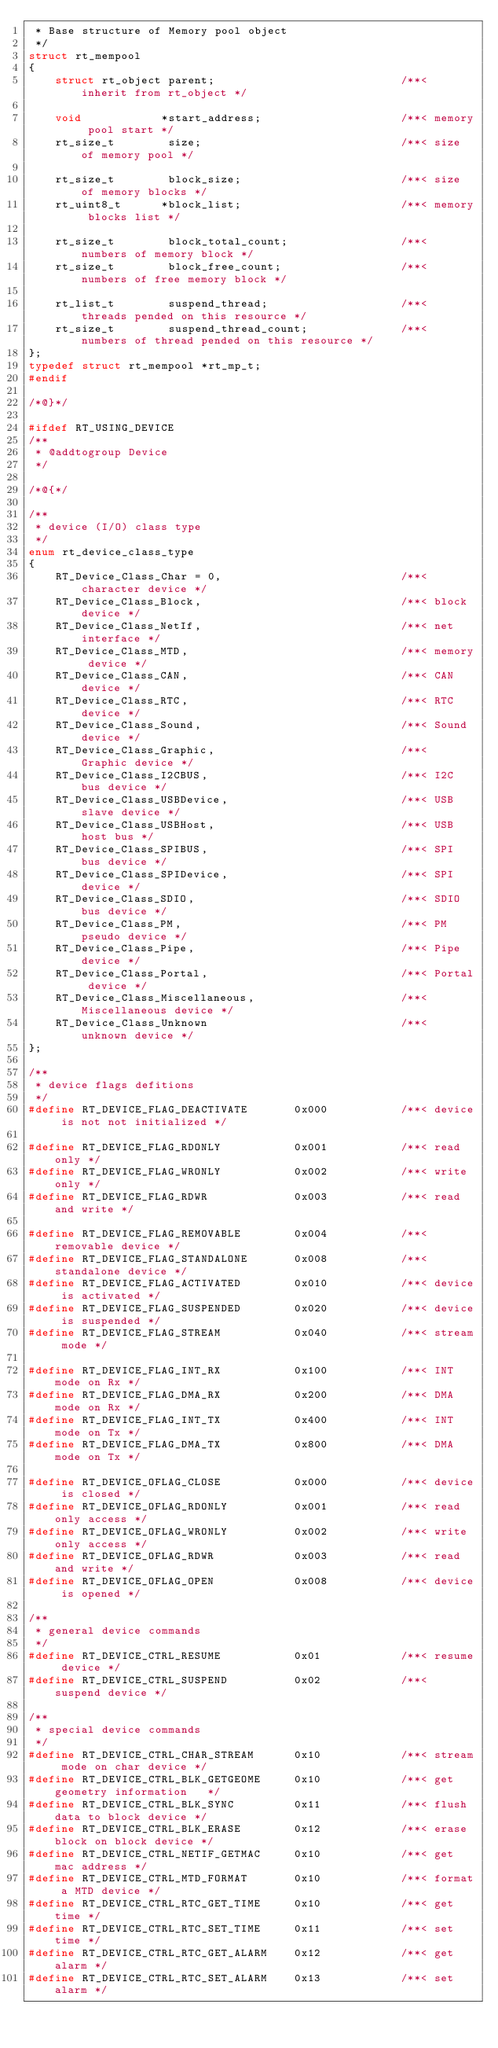Convert code to text. <code><loc_0><loc_0><loc_500><loc_500><_C_> * Base structure of Memory pool object
 */
struct rt_mempool
{
    struct rt_object parent;                            /**< inherit from rt_object */

    void            *start_address;                     /**< memory pool start */
    rt_size_t        size;                              /**< size of memory pool */

    rt_size_t        block_size;                        /**< size of memory blocks */
    rt_uint8_t      *block_list;                        /**< memory blocks list */

    rt_size_t        block_total_count;                 /**< numbers of memory block */
    rt_size_t        block_free_count;                  /**< numbers of free memory block */

    rt_list_t        suspend_thread;                    /**< threads pended on this resource */
    rt_size_t        suspend_thread_count;              /**< numbers of thread pended on this resource */
};
typedef struct rt_mempool *rt_mp_t;
#endif

/*@}*/

#ifdef RT_USING_DEVICE
/**
 * @addtogroup Device
 */

/*@{*/

/**
 * device (I/O) class type
 */
enum rt_device_class_type
{
    RT_Device_Class_Char = 0,                           /**< character device */
    RT_Device_Class_Block,                              /**< block device */
    RT_Device_Class_NetIf,                              /**< net interface */
    RT_Device_Class_MTD,                                /**< memory device */
    RT_Device_Class_CAN,                                /**< CAN device */
    RT_Device_Class_RTC,                                /**< RTC device */
    RT_Device_Class_Sound,                              /**< Sound device */
    RT_Device_Class_Graphic,                            /**< Graphic device */
    RT_Device_Class_I2CBUS,                             /**< I2C bus device */
    RT_Device_Class_USBDevice,                          /**< USB slave device */
    RT_Device_Class_USBHost,                            /**< USB host bus */
    RT_Device_Class_SPIBUS,                             /**< SPI bus device */
    RT_Device_Class_SPIDevice,                          /**< SPI device */
    RT_Device_Class_SDIO,                               /**< SDIO bus device */
    RT_Device_Class_PM,                                 /**< PM pseudo device */
    RT_Device_Class_Pipe,                               /**< Pipe device */
    RT_Device_Class_Portal,                             /**< Portal device */
    RT_Device_Class_Miscellaneous,                      /**< Miscellaneous device */
    RT_Device_Class_Unknown                             /**< unknown device */
};

/**
 * device flags defitions
 */
#define RT_DEVICE_FLAG_DEACTIVATE       0x000           /**< device is not not initialized */

#define RT_DEVICE_FLAG_RDONLY           0x001           /**< read only */
#define RT_DEVICE_FLAG_WRONLY           0x002           /**< write only */
#define RT_DEVICE_FLAG_RDWR             0x003           /**< read and write */

#define RT_DEVICE_FLAG_REMOVABLE        0x004           /**< removable device */
#define RT_DEVICE_FLAG_STANDALONE       0x008           /**< standalone device */
#define RT_DEVICE_FLAG_ACTIVATED        0x010           /**< device is activated */
#define RT_DEVICE_FLAG_SUSPENDED        0x020           /**< device is suspended */
#define RT_DEVICE_FLAG_STREAM           0x040           /**< stream mode */

#define RT_DEVICE_FLAG_INT_RX           0x100           /**< INT mode on Rx */
#define RT_DEVICE_FLAG_DMA_RX           0x200           /**< DMA mode on Rx */
#define RT_DEVICE_FLAG_INT_TX           0x400           /**< INT mode on Tx */
#define RT_DEVICE_FLAG_DMA_TX           0x800           /**< DMA mode on Tx */

#define RT_DEVICE_OFLAG_CLOSE           0x000           /**< device is closed */
#define RT_DEVICE_OFLAG_RDONLY          0x001           /**< read only access */
#define RT_DEVICE_OFLAG_WRONLY          0x002           /**< write only access */
#define RT_DEVICE_OFLAG_RDWR            0x003           /**< read and write */
#define RT_DEVICE_OFLAG_OPEN            0x008           /**< device is opened */

/**
 * general device commands
 */
#define RT_DEVICE_CTRL_RESUME           0x01            /**< resume device */
#define RT_DEVICE_CTRL_SUSPEND          0x02            /**< suspend device */

/**
 * special device commands
 */
#define RT_DEVICE_CTRL_CHAR_STREAM      0x10            /**< stream mode on char device */
#define RT_DEVICE_CTRL_BLK_GETGEOME     0x10            /**< get geometry information   */
#define RT_DEVICE_CTRL_BLK_SYNC         0x11            /**< flush data to block device */
#define RT_DEVICE_CTRL_BLK_ERASE        0x12            /**< erase block on block device */
#define RT_DEVICE_CTRL_NETIF_GETMAC     0x10            /**< get mac address */
#define RT_DEVICE_CTRL_MTD_FORMAT       0x10            /**< format a MTD device */
#define RT_DEVICE_CTRL_RTC_GET_TIME     0x10            /**< get time */
#define RT_DEVICE_CTRL_RTC_SET_TIME     0x11            /**< set time */
#define RT_DEVICE_CTRL_RTC_GET_ALARM    0x12            /**< get alarm */
#define RT_DEVICE_CTRL_RTC_SET_ALARM    0x13            /**< set alarm */
</code> 